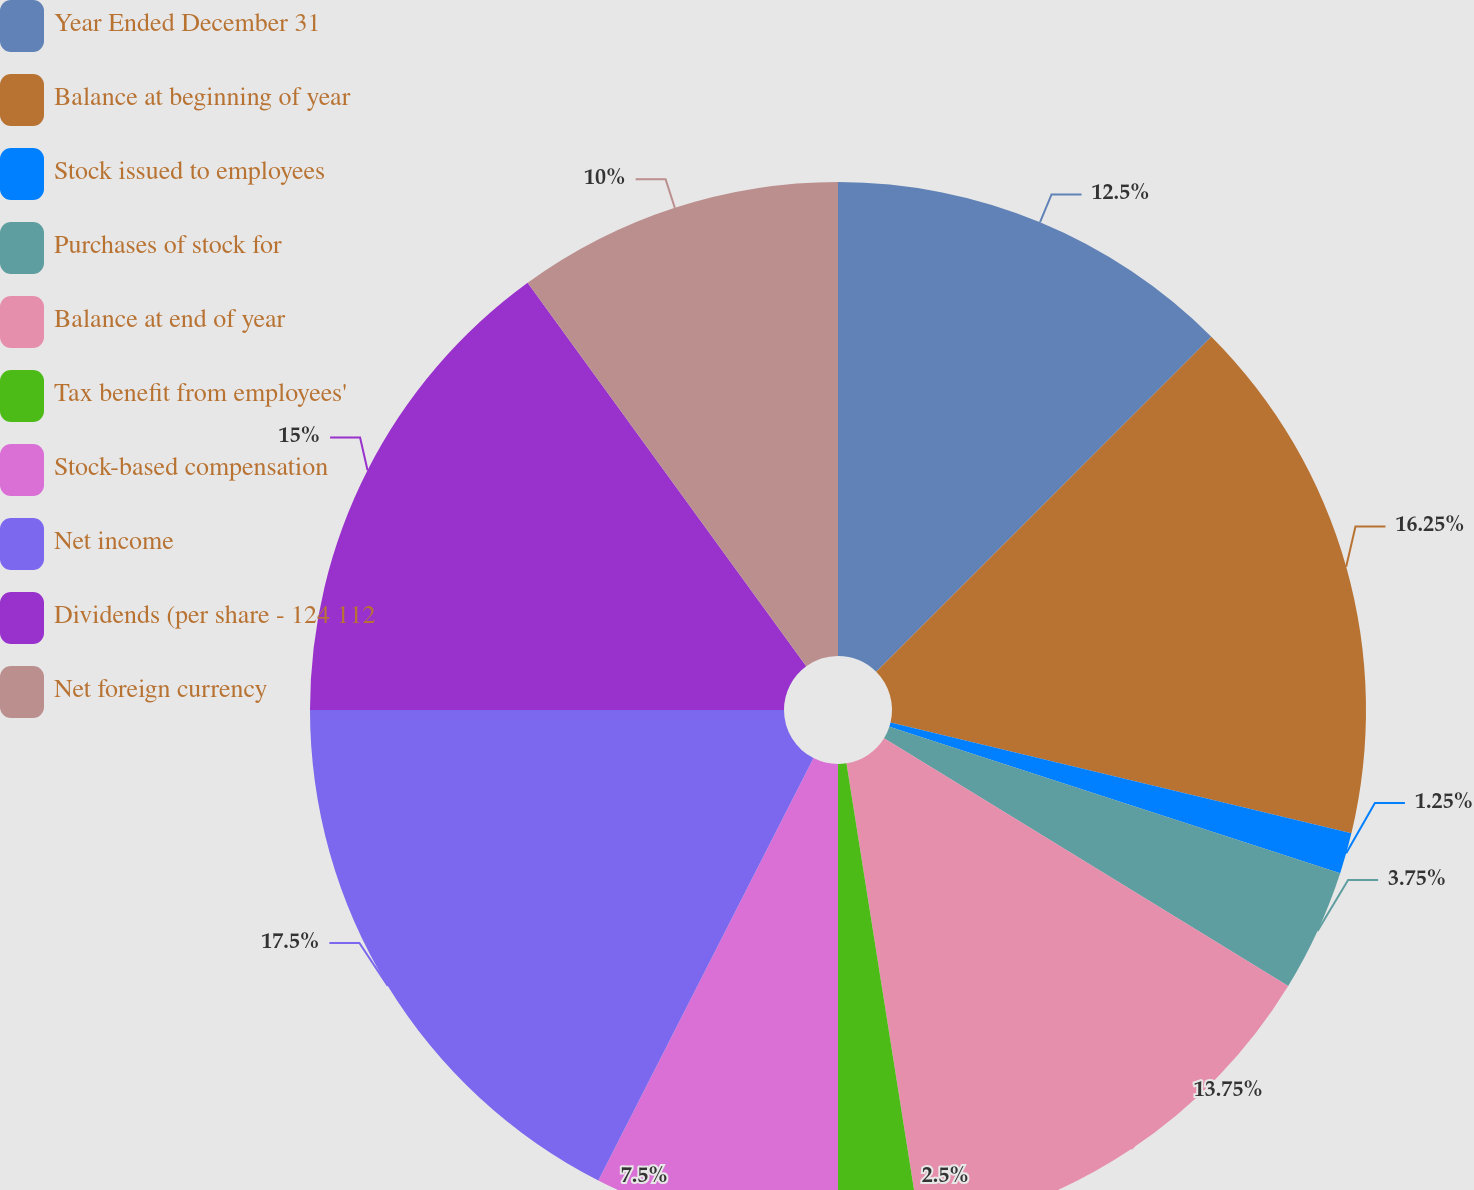Convert chart. <chart><loc_0><loc_0><loc_500><loc_500><pie_chart><fcel>Year Ended December 31<fcel>Balance at beginning of year<fcel>Stock issued to employees<fcel>Purchases of stock for<fcel>Balance at end of year<fcel>Tax benefit from employees'<fcel>Stock-based compensation<fcel>Net income<fcel>Dividends (per share - 124 112<fcel>Net foreign currency<nl><fcel>12.5%<fcel>16.25%<fcel>1.25%<fcel>3.75%<fcel>13.75%<fcel>2.5%<fcel>7.5%<fcel>17.5%<fcel>15.0%<fcel>10.0%<nl></chart> 